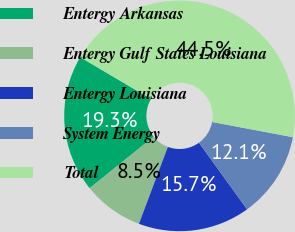<chart> <loc_0><loc_0><loc_500><loc_500><pie_chart><fcel>Entergy Arkansas<fcel>Entergy Gulf States Louisiana<fcel>Entergy Louisiana<fcel>System Energy<fcel>Total<nl><fcel>19.28%<fcel>8.49%<fcel>15.68%<fcel>12.08%<fcel>44.47%<nl></chart> 